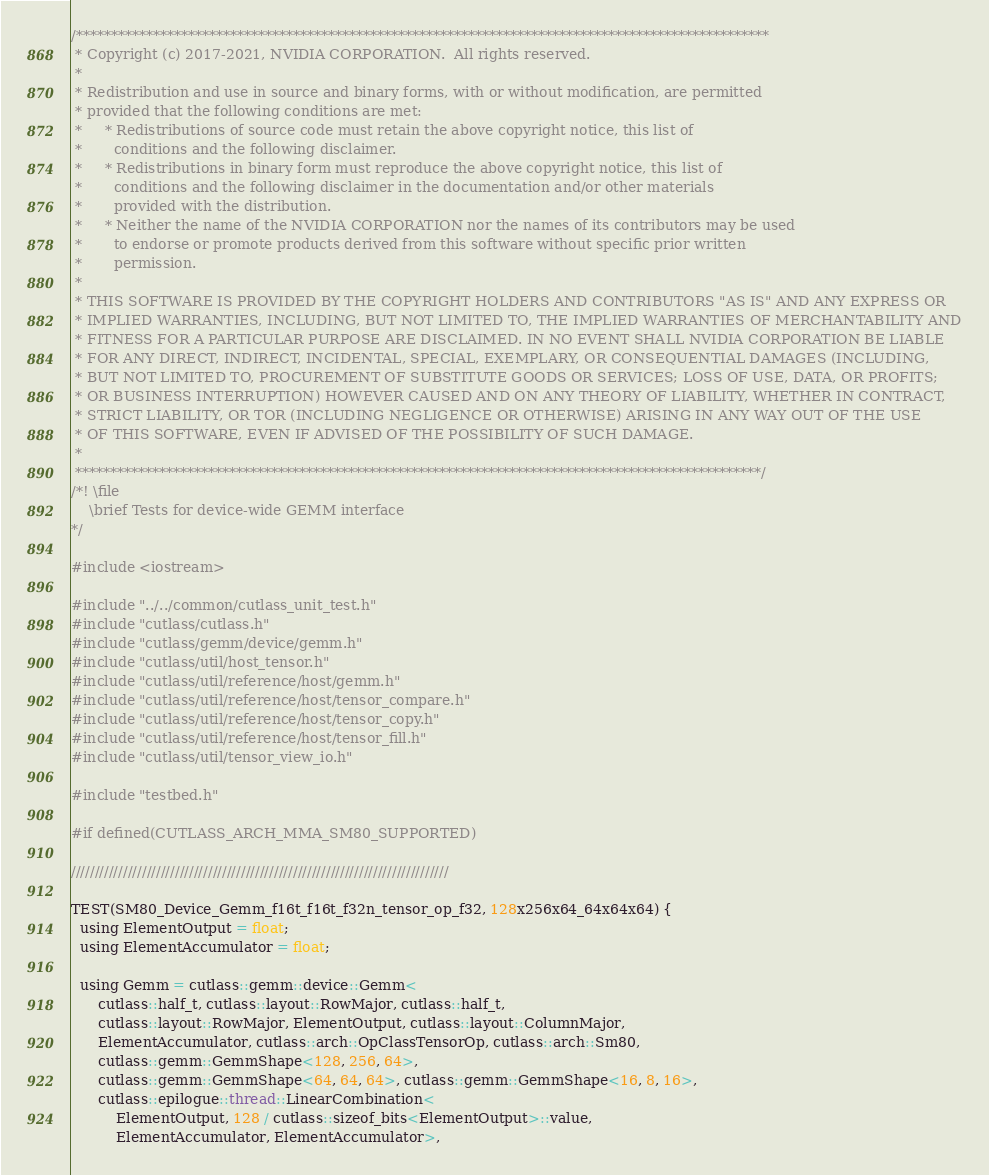<code> <loc_0><loc_0><loc_500><loc_500><_Cuda_>/***************************************************************************************************
 * Copyright (c) 2017-2021, NVIDIA CORPORATION.  All rights reserved.
 *
 * Redistribution and use in source and binary forms, with or without modification, are permitted
 * provided that the following conditions are met:
 *     * Redistributions of source code must retain the above copyright notice, this list of
 *       conditions and the following disclaimer.
 *     * Redistributions in binary form must reproduce the above copyright notice, this list of
 *       conditions and the following disclaimer in the documentation and/or other materials
 *       provided with the distribution.
 *     * Neither the name of the NVIDIA CORPORATION nor the names of its contributors may be used
 *       to endorse or promote products derived from this software without specific prior written
 *       permission.
 *
 * THIS SOFTWARE IS PROVIDED BY THE COPYRIGHT HOLDERS AND CONTRIBUTORS "AS IS" AND ANY EXPRESS OR
 * IMPLIED WARRANTIES, INCLUDING, BUT NOT LIMITED TO, THE IMPLIED WARRANTIES OF MERCHANTABILITY AND
 * FITNESS FOR A PARTICULAR PURPOSE ARE DISCLAIMED. IN NO EVENT SHALL NVIDIA CORPORATION BE LIABLE
 * FOR ANY DIRECT, INDIRECT, INCIDENTAL, SPECIAL, EXEMPLARY, OR CONSEQUENTIAL DAMAGES (INCLUDING,
 * BUT NOT LIMITED TO, PROCUREMENT OF SUBSTITUTE GOODS OR SERVICES; LOSS OF USE, DATA, OR PROFITS;
 * OR BUSINESS INTERRUPTION) HOWEVER CAUSED AND ON ANY THEORY OF LIABILITY, WHETHER IN CONTRACT,
 * STRICT LIABILITY, OR TOR (INCLUDING NEGLIGENCE OR OTHERWISE) ARISING IN ANY WAY OUT OF THE USE
 * OF THIS SOFTWARE, EVEN IF ADVISED OF THE POSSIBILITY OF SUCH DAMAGE.
 *
 **************************************************************************************************/
/*! \file
    \brief Tests for device-wide GEMM interface
*/

#include <iostream>

#include "../../common/cutlass_unit_test.h"
#include "cutlass/cutlass.h"
#include "cutlass/gemm/device/gemm.h"
#include "cutlass/util/host_tensor.h"
#include "cutlass/util/reference/host/gemm.h"
#include "cutlass/util/reference/host/tensor_compare.h"
#include "cutlass/util/reference/host/tensor_copy.h"
#include "cutlass/util/reference/host/tensor_fill.h"
#include "cutlass/util/tensor_view_io.h"

#include "testbed.h"

#if defined(CUTLASS_ARCH_MMA_SM80_SUPPORTED)

////////////////////////////////////////////////////////////////////////////////

TEST(SM80_Device_Gemm_f16t_f16t_f32n_tensor_op_f32, 128x256x64_64x64x64) {
  using ElementOutput = float;
  using ElementAccumulator = float;

  using Gemm = cutlass::gemm::device::Gemm<
      cutlass::half_t, cutlass::layout::RowMajor, cutlass::half_t,
      cutlass::layout::RowMajor, ElementOutput, cutlass::layout::ColumnMajor,
      ElementAccumulator, cutlass::arch::OpClassTensorOp, cutlass::arch::Sm80,
      cutlass::gemm::GemmShape<128, 256, 64>,
      cutlass::gemm::GemmShape<64, 64, 64>, cutlass::gemm::GemmShape<16, 8, 16>,
      cutlass::epilogue::thread::LinearCombination<
          ElementOutput, 128 / cutlass::sizeof_bits<ElementOutput>::value,
          ElementAccumulator, ElementAccumulator>,</code> 